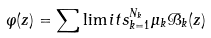<formula> <loc_0><loc_0><loc_500><loc_500>\varphi ( z ) = \sum \lim i t s _ { k = 1 } ^ { N _ { k } } { \mu } _ { k } { \mathcal { B } } _ { k } ( z )</formula> 